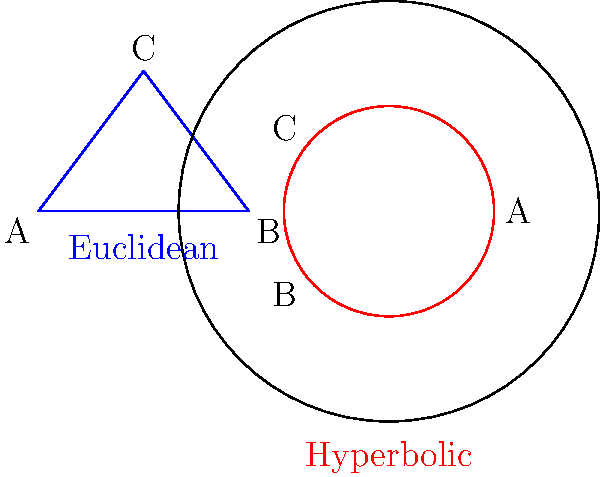Consider the two triangles shown above: a Euclidean triangle (left, blue) and a hyperbolic triangle (right, red) in the Poincaré disk model. If both triangles have the same side lengths, how does the area of the hyperbolic triangle compare to the area of the Euclidean triangle? To understand the difference in area calculation between Euclidean and hyperbolic geometry:

1. Euclidean Triangle Area:
   - In Euclidean geometry, the area of a triangle is calculated using the formula: $A = \frac{1}{2}bh$, where $b$ is the base and $h$ is the height.
   - The area is independent of the triangle's position or orientation in the plane.

2. Hyperbolic Triangle Area:
   - In hyperbolic geometry, the area of a triangle is calculated using the Gauss-Bonnet formula: $A = \pi - (\alpha + \beta + \gamma)$, where $\alpha$, $\beta$, and $\gamma$ are the interior angles of the triangle.
   - The sum of the interior angles of a hyperbolic triangle is always less than $\pi$ (180°).

3. Comparison:
   - For triangles with the same side lengths:
     a. In Euclidean geometry, the area remains constant.
     b. In hyperbolic geometry, the area is always smaller than its Euclidean counterpart.
   - This is because the curvature of hyperbolic space causes the interior angles to be smaller, resulting in a smaller area.

4. Visual Representation:
   - In the Poincaré disk model (right figure), straight lines in hyperbolic geometry are represented as arcs of circles perpendicular to the boundary circle.
   - The hyperbolic triangle appears distorted and smaller compared to the Euclidean triangle, even though they have the same side lengths.

5. Conclusion:
   - The area of the hyperbolic triangle is always smaller than the area of the Euclidean triangle with the same side lengths.
Answer: The hyperbolic triangle has a smaller area than the Euclidean triangle. 